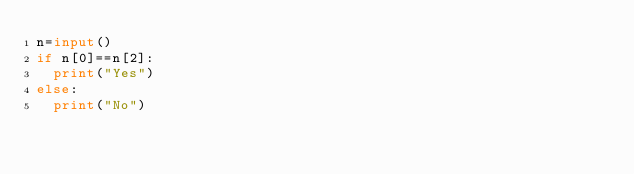Convert code to text. <code><loc_0><loc_0><loc_500><loc_500><_Python_>n=input()
if n[0]==n[2]:
  print("Yes")
else:
  print("No")</code> 